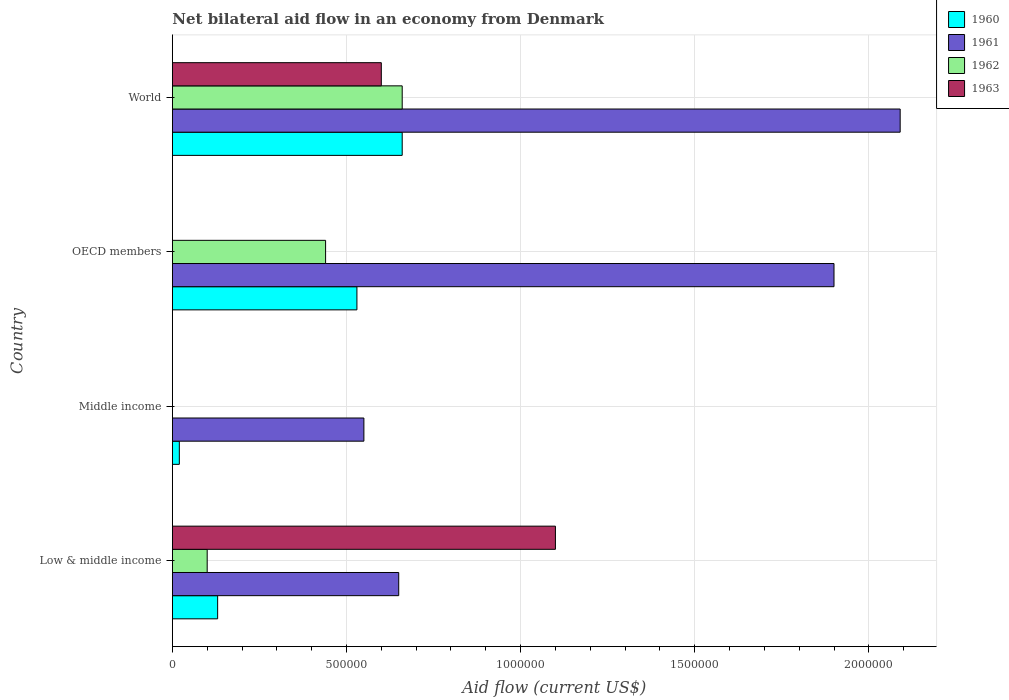How many groups of bars are there?
Offer a very short reply. 4. What is the label of the 2nd group of bars from the top?
Your answer should be compact. OECD members. In how many cases, is the number of bars for a given country not equal to the number of legend labels?
Provide a succinct answer. 2. What is the net bilateral aid flow in 1960 in OECD members?
Offer a terse response. 5.30e+05. Across all countries, what is the maximum net bilateral aid flow in 1962?
Ensure brevity in your answer.  6.60e+05. What is the total net bilateral aid flow in 1963 in the graph?
Your answer should be very brief. 1.70e+06. What is the difference between the net bilateral aid flow in 1960 in Low & middle income and that in World?
Provide a succinct answer. -5.30e+05. What is the difference between the net bilateral aid flow in 1960 in Middle income and the net bilateral aid flow in 1961 in World?
Provide a succinct answer. -2.07e+06. What is the average net bilateral aid flow in 1961 per country?
Your answer should be very brief. 1.30e+06. What is the difference between the net bilateral aid flow in 1962 and net bilateral aid flow in 1960 in OECD members?
Ensure brevity in your answer.  -9.00e+04. What is the ratio of the net bilateral aid flow in 1961 in Middle income to that in OECD members?
Offer a terse response. 0.29. Is the net bilateral aid flow in 1960 in Middle income less than that in OECD members?
Provide a succinct answer. Yes. Is the difference between the net bilateral aid flow in 1962 in OECD members and World greater than the difference between the net bilateral aid flow in 1960 in OECD members and World?
Your response must be concise. No. What is the difference between the highest and the lowest net bilateral aid flow in 1961?
Keep it short and to the point. 1.54e+06. Is the sum of the net bilateral aid flow in 1960 in Middle income and OECD members greater than the maximum net bilateral aid flow in 1963 across all countries?
Your answer should be compact. No. Is it the case that in every country, the sum of the net bilateral aid flow in 1962 and net bilateral aid flow in 1961 is greater than the net bilateral aid flow in 1963?
Ensure brevity in your answer.  No. How many countries are there in the graph?
Your response must be concise. 4. Are the values on the major ticks of X-axis written in scientific E-notation?
Offer a very short reply. No. Does the graph contain any zero values?
Provide a short and direct response. Yes. Does the graph contain grids?
Give a very brief answer. Yes. Where does the legend appear in the graph?
Provide a short and direct response. Top right. How many legend labels are there?
Your answer should be compact. 4. What is the title of the graph?
Offer a very short reply. Net bilateral aid flow in an economy from Denmark. Does "2012" appear as one of the legend labels in the graph?
Offer a terse response. No. What is the Aid flow (current US$) in 1960 in Low & middle income?
Provide a short and direct response. 1.30e+05. What is the Aid flow (current US$) of 1961 in Low & middle income?
Give a very brief answer. 6.50e+05. What is the Aid flow (current US$) in 1962 in Low & middle income?
Your answer should be compact. 1.00e+05. What is the Aid flow (current US$) in 1963 in Low & middle income?
Give a very brief answer. 1.10e+06. What is the Aid flow (current US$) of 1960 in Middle income?
Offer a terse response. 2.00e+04. What is the Aid flow (current US$) in 1961 in Middle income?
Provide a succinct answer. 5.50e+05. What is the Aid flow (current US$) in 1962 in Middle income?
Provide a short and direct response. 0. What is the Aid flow (current US$) of 1963 in Middle income?
Your response must be concise. 0. What is the Aid flow (current US$) in 1960 in OECD members?
Your response must be concise. 5.30e+05. What is the Aid flow (current US$) of 1961 in OECD members?
Give a very brief answer. 1.90e+06. What is the Aid flow (current US$) of 1961 in World?
Give a very brief answer. 2.09e+06. Across all countries, what is the maximum Aid flow (current US$) in 1961?
Your response must be concise. 2.09e+06. Across all countries, what is the maximum Aid flow (current US$) in 1963?
Ensure brevity in your answer.  1.10e+06. Across all countries, what is the minimum Aid flow (current US$) of 1960?
Your answer should be very brief. 2.00e+04. Across all countries, what is the minimum Aid flow (current US$) of 1961?
Offer a very short reply. 5.50e+05. Across all countries, what is the minimum Aid flow (current US$) in 1962?
Your answer should be compact. 0. Across all countries, what is the minimum Aid flow (current US$) of 1963?
Make the answer very short. 0. What is the total Aid flow (current US$) in 1960 in the graph?
Give a very brief answer. 1.34e+06. What is the total Aid flow (current US$) in 1961 in the graph?
Your answer should be compact. 5.19e+06. What is the total Aid flow (current US$) in 1962 in the graph?
Offer a terse response. 1.20e+06. What is the total Aid flow (current US$) of 1963 in the graph?
Ensure brevity in your answer.  1.70e+06. What is the difference between the Aid flow (current US$) in 1960 in Low & middle income and that in Middle income?
Your response must be concise. 1.10e+05. What is the difference between the Aid flow (current US$) in 1961 in Low & middle income and that in Middle income?
Make the answer very short. 1.00e+05. What is the difference between the Aid flow (current US$) in 1960 in Low & middle income and that in OECD members?
Your answer should be very brief. -4.00e+05. What is the difference between the Aid flow (current US$) of 1961 in Low & middle income and that in OECD members?
Keep it short and to the point. -1.25e+06. What is the difference between the Aid flow (current US$) in 1960 in Low & middle income and that in World?
Provide a succinct answer. -5.30e+05. What is the difference between the Aid flow (current US$) in 1961 in Low & middle income and that in World?
Provide a succinct answer. -1.44e+06. What is the difference between the Aid flow (current US$) of 1962 in Low & middle income and that in World?
Give a very brief answer. -5.60e+05. What is the difference between the Aid flow (current US$) in 1960 in Middle income and that in OECD members?
Your answer should be compact. -5.10e+05. What is the difference between the Aid flow (current US$) in 1961 in Middle income and that in OECD members?
Your response must be concise. -1.35e+06. What is the difference between the Aid flow (current US$) of 1960 in Middle income and that in World?
Make the answer very short. -6.40e+05. What is the difference between the Aid flow (current US$) in 1961 in Middle income and that in World?
Your answer should be compact. -1.54e+06. What is the difference between the Aid flow (current US$) in 1962 in OECD members and that in World?
Provide a short and direct response. -2.20e+05. What is the difference between the Aid flow (current US$) of 1960 in Low & middle income and the Aid flow (current US$) of 1961 in Middle income?
Ensure brevity in your answer.  -4.20e+05. What is the difference between the Aid flow (current US$) of 1960 in Low & middle income and the Aid flow (current US$) of 1961 in OECD members?
Provide a succinct answer. -1.77e+06. What is the difference between the Aid flow (current US$) of 1960 in Low & middle income and the Aid flow (current US$) of 1962 in OECD members?
Offer a terse response. -3.10e+05. What is the difference between the Aid flow (current US$) of 1961 in Low & middle income and the Aid flow (current US$) of 1962 in OECD members?
Offer a terse response. 2.10e+05. What is the difference between the Aid flow (current US$) in 1960 in Low & middle income and the Aid flow (current US$) in 1961 in World?
Keep it short and to the point. -1.96e+06. What is the difference between the Aid flow (current US$) of 1960 in Low & middle income and the Aid flow (current US$) of 1962 in World?
Your answer should be compact. -5.30e+05. What is the difference between the Aid flow (current US$) in 1960 in Low & middle income and the Aid flow (current US$) in 1963 in World?
Your answer should be very brief. -4.70e+05. What is the difference between the Aid flow (current US$) in 1961 in Low & middle income and the Aid flow (current US$) in 1962 in World?
Provide a succinct answer. -10000. What is the difference between the Aid flow (current US$) of 1961 in Low & middle income and the Aid flow (current US$) of 1963 in World?
Make the answer very short. 5.00e+04. What is the difference between the Aid flow (current US$) of 1962 in Low & middle income and the Aid flow (current US$) of 1963 in World?
Offer a very short reply. -5.00e+05. What is the difference between the Aid flow (current US$) of 1960 in Middle income and the Aid flow (current US$) of 1961 in OECD members?
Provide a short and direct response. -1.88e+06. What is the difference between the Aid flow (current US$) of 1960 in Middle income and the Aid flow (current US$) of 1962 in OECD members?
Keep it short and to the point. -4.20e+05. What is the difference between the Aid flow (current US$) in 1961 in Middle income and the Aid flow (current US$) in 1962 in OECD members?
Provide a short and direct response. 1.10e+05. What is the difference between the Aid flow (current US$) of 1960 in Middle income and the Aid flow (current US$) of 1961 in World?
Provide a short and direct response. -2.07e+06. What is the difference between the Aid flow (current US$) of 1960 in Middle income and the Aid flow (current US$) of 1962 in World?
Keep it short and to the point. -6.40e+05. What is the difference between the Aid flow (current US$) in 1960 in Middle income and the Aid flow (current US$) in 1963 in World?
Keep it short and to the point. -5.80e+05. What is the difference between the Aid flow (current US$) of 1961 in Middle income and the Aid flow (current US$) of 1963 in World?
Keep it short and to the point. -5.00e+04. What is the difference between the Aid flow (current US$) in 1960 in OECD members and the Aid flow (current US$) in 1961 in World?
Your response must be concise. -1.56e+06. What is the difference between the Aid flow (current US$) of 1960 in OECD members and the Aid flow (current US$) of 1962 in World?
Offer a terse response. -1.30e+05. What is the difference between the Aid flow (current US$) of 1960 in OECD members and the Aid flow (current US$) of 1963 in World?
Your response must be concise. -7.00e+04. What is the difference between the Aid flow (current US$) of 1961 in OECD members and the Aid flow (current US$) of 1962 in World?
Make the answer very short. 1.24e+06. What is the difference between the Aid flow (current US$) of 1961 in OECD members and the Aid flow (current US$) of 1963 in World?
Your response must be concise. 1.30e+06. What is the difference between the Aid flow (current US$) in 1962 in OECD members and the Aid flow (current US$) in 1963 in World?
Keep it short and to the point. -1.60e+05. What is the average Aid flow (current US$) in 1960 per country?
Provide a succinct answer. 3.35e+05. What is the average Aid flow (current US$) of 1961 per country?
Provide a short and direct response. 1.30e+06. What is the average Aid flow (current US$) of 1962 per country?
Ensure brevity in your answer.  3.00e+05. What is the average Aid flow (current US$) of 1963 per country?
Your response must be concise. 4.25e+05. What is the difference between the Aid flow (current US$) of 1960 and Aid flow (current US$) of 1961 in Low & middle income?
Provide a succinct answer. -5.20e+05. What is the difference between the Aid flow (current US$) in 1960 and Aid flow (current US$) in 1962 in Low & middle income?
Make the answer very short. 3.00e+04. What is the difference between the Aid flow (current US$) of 1960 and Aid flow (current US$) of 1963 in Low & middle income?
Your answer should be very brief. -9.70e+05. What is the difference between the Aid flow (current US$) in 1961 and Aid flow (current US$) in 1962 in Low & middle income?
Ensure brevity in your answer.  5.50e+05. What is the difference between the Aid flow (current US$) of 1961 and Aid flow (current US$) of 1963 in Low & middle income?
Offer a terse response. -4.50e+05. What is the difference between the Aid flow (current US$) of 1962 and Aid flow (current US$) of 1963 in Low & middle income?
Provide a succinct answer. -1.00e+06. What is the difference between the Aid flow (current US$) of 1960 and Aid flow (current US$) of 1961 in Middle income?
Provide a short and direct response. -5.30e+05. What is the difference between the Aid flow (current US$) in 1960 and Aid flow (current US$) in 1961 in OECD members?
Keep it short and to the point. -1.37e+06. What is the difference between the Aid flow (current US$) in 1961 and Aid flow (current US$) in 1962 in OECD members?
Ensure brevity in your answer.  1.46e+06. What is the difference between the Aid flow (current US$) of 1960 and Aid flow (current US$) of 1961 in World?
Make the answer very short. -1.43e+06. What is the difference between the Aid flow (current US$) in 1960 and Aid flow (current US$) in 1962 in World?
Offer a very short reply. 0. What is the difference between the Aid flow (current US$) in 1960 and Aid flow (current US$) in 1963 in World?
Make the answer very short. 6.00e+04. What is the difference between the Aid flow (current US$) of 1961 and Aid flow (current US$) of 1962 in World?
Your answer should be very brief. 1.43e+06. What is the difference between the Aid flow (current US$) in 1961 and Aid flow (current US$) in 1963 in World?
Your answer should be compact. 1.49e+06. What is the difference between the Aid flow (current US$) in 1962 and Aid flow (current US$) in 1963 in World?
Offer a very short reply. 6.00e+04. What is the ratio of the Aid flow (current US$) in 1961 in Low & middle income to that in Middle income?
Your answer should be compact. 1.18. What is the ratio of the Aid flow (current US$) of 1960 in Low & middle income to that in OECD members?
Provide a short and direct response. 0.25. What is the ratio of the Aid flow (current US$) of 1961 in Low & middle income to that in OECD members?
Your answer should be very brief. 0.34. What is the ratio of the Aid flow (current US$) of 1962 in Low & middle income to that in OECD members?
Provide a succinct answer. 0.23. What is the ratio of the Aid flow (current US$) in 1960 in Low & middle income to that in World?
Give a very brief answer. 0.2. What is the ratio of the Aid flow (current US$) of 1961 in Low & middle income to that in World?
Your answer should be compact. 0.31. What is the ratio of the Aid flow (current US$) of 1962 in Low & middle income to that in World?
Your answer should be very brief. 0.15. What is the ratio of the Aid flow (current US$) in 1963 in Low & middle income to that in World?
Give a very brief answer. 1.83. What is the ratio of the Aid flow (current US$) in 1960 in Middle income to that in OECD members?
Offer a terse response. 0.04. What is the ratio of the Aid flow (current US$) of 1961 in Middle income to that in OECD members?
Keep it short and to the point. 0.29. What is the ratio of the Aid flow (current US$) of 1960 in Middle income to that in World?
Keep it short and to the point. 0.03. What is the ratio of the Aid flow (current US$) in 1961 in Middle income to that in World?
Ensure brevity in your answer.  0.26. What is the ratio of the Aid flow (current US$) in 1960 in OECD members to that in World?
Offer a very short reply. 0.8. What is the ratio of the Aid flow (current US$) in 1961 in OECD members to that in World?
Make the answer very short. 0.91. What is the difference between the highest and the second highest Aid flow (current US$) in 1960?
Provide a short and direct response. 1.30e+05. What is the difference between the highest and the second highest Aid flow (current US$) in 1961?
Make the answer very short. 1.90e+05. What is the difference between the highest and the lowest Aid flow (current US$) of 1960?
Keep it short and to the point. 6.40e+05. What is the difference between the highest and the lowest Aid flow (current US$) in 1961?
Offer a terse response. 1.54e+06. What is the difference between the highest and the lowest Aid flow (current US$) in 1963?
Ensure brevity in your answer.  1.10e+06. 